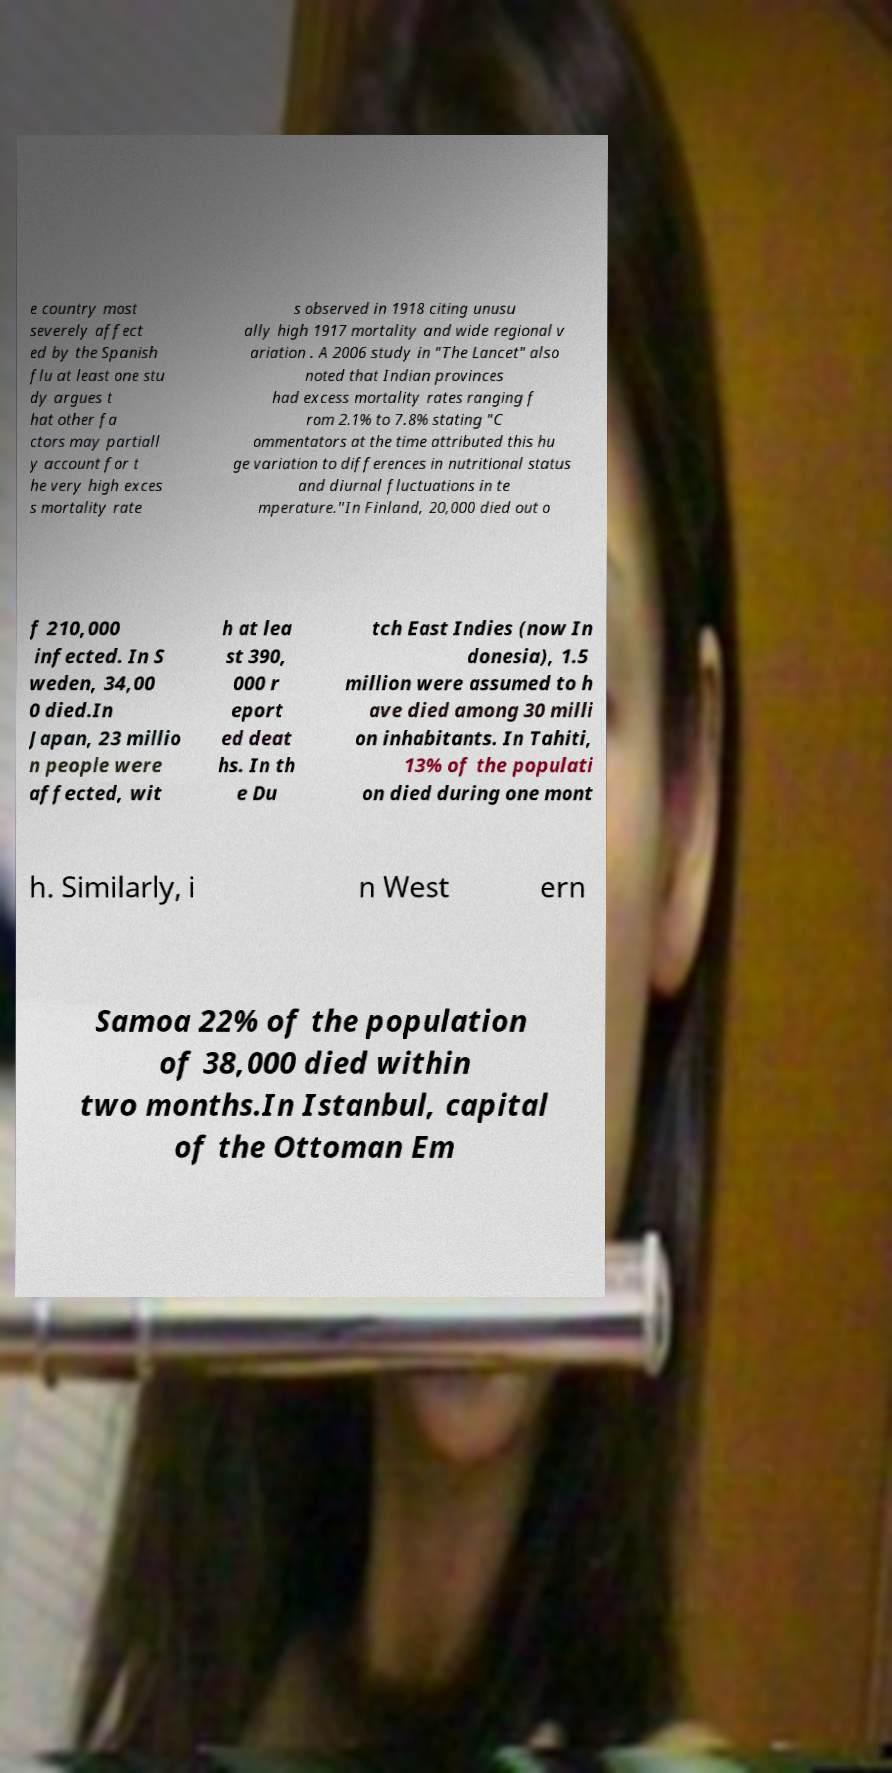Could you extract and type out the text from this image? e country most severely affect ed by the Spanish flu at least one stu dy argues t hat other fa ctors may partiall y account for t he very high exces s mortality rate s observed in 1918 citing unusu ally high 1917 mortality and wide regional v ariation . A 2006 study in "The Lancet" also noted that Indian provinces had excess mortality rates ranging f rom 2.1% to 7.8% stating "C ommentators at the time attributed this hu ge variation to differences in nutritional status and diurnal fluctuations in te mperature."In Finland, 20,000 died out o f 210,000 infected. In S weden, 34,00 0 died.In Japan, 23 millio n people were affected, wit h at lea st 390, 000 r eport ed deat hs. In th e Du tch East Indies (now In donesia), 1.5 million were assumed to h ave died among 30 milli on inhabitants. In Tahiti, 13% of the populati on died during one mont h. Similarly, i n West ern Samoa 22% of the population of 38,000 died within two months.In Istanbul, capital of the Ottoman Em 